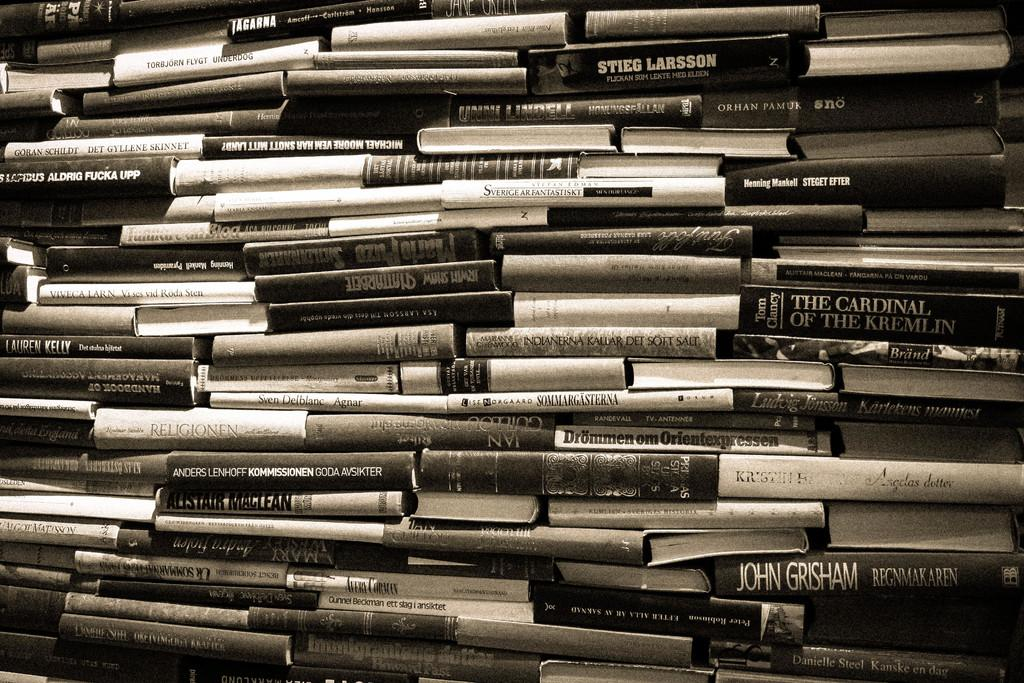<image>
Summarize the visual content of the image. A large stack of books includes one by John Grisham. 